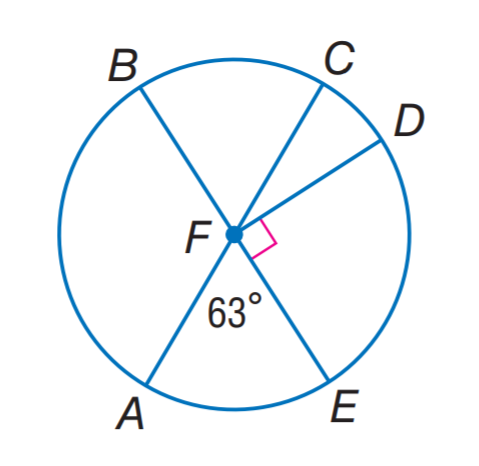Answer the mathemtical geometry problem and directly provide the correct option letter.
Question: In \odot F, find m \widehat A D B.
Choices: A: 63 B: 153 C: 233 D: 243 D 